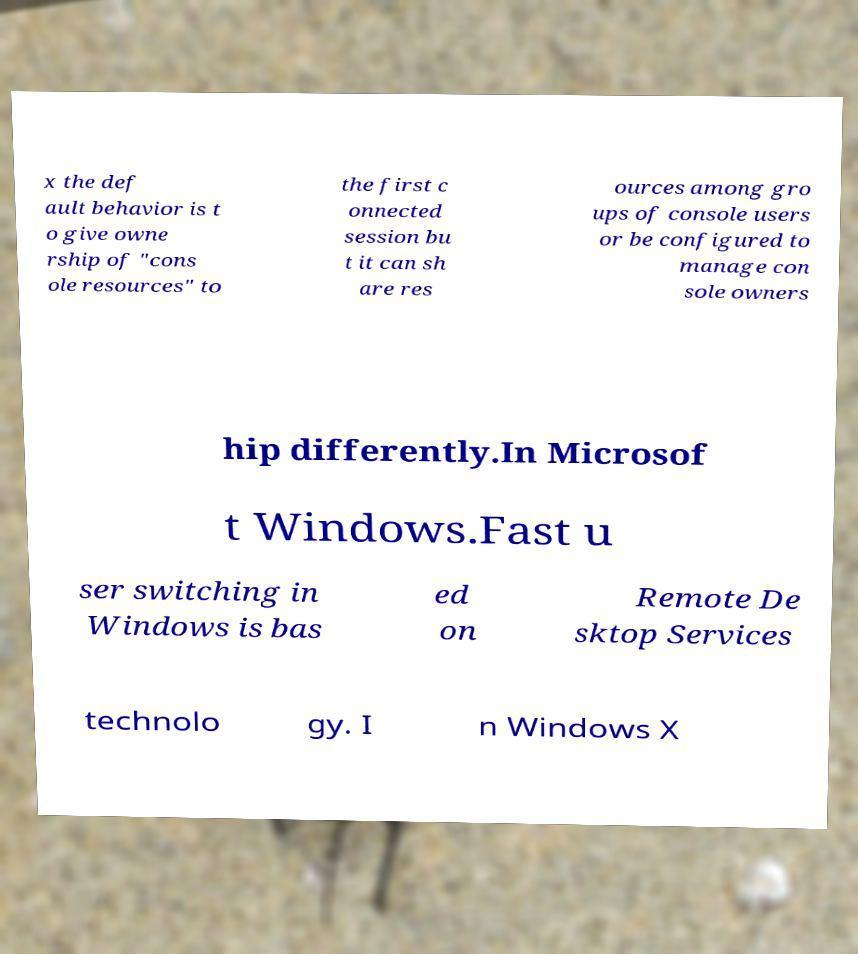What messages or text are displayed in this image? I need them in a readable, typed format. x the def ault behavior is t o give owne rship of "cons ole resources" to the first c onnected session bu t it can sh are res ources among gro ups of console users or be configured to manage con sole owners hip differently.In Microsof t Windows.Fast u ser switching in Windows is bas ed on Remote De sktop Services technolo gy. I n Windows X 